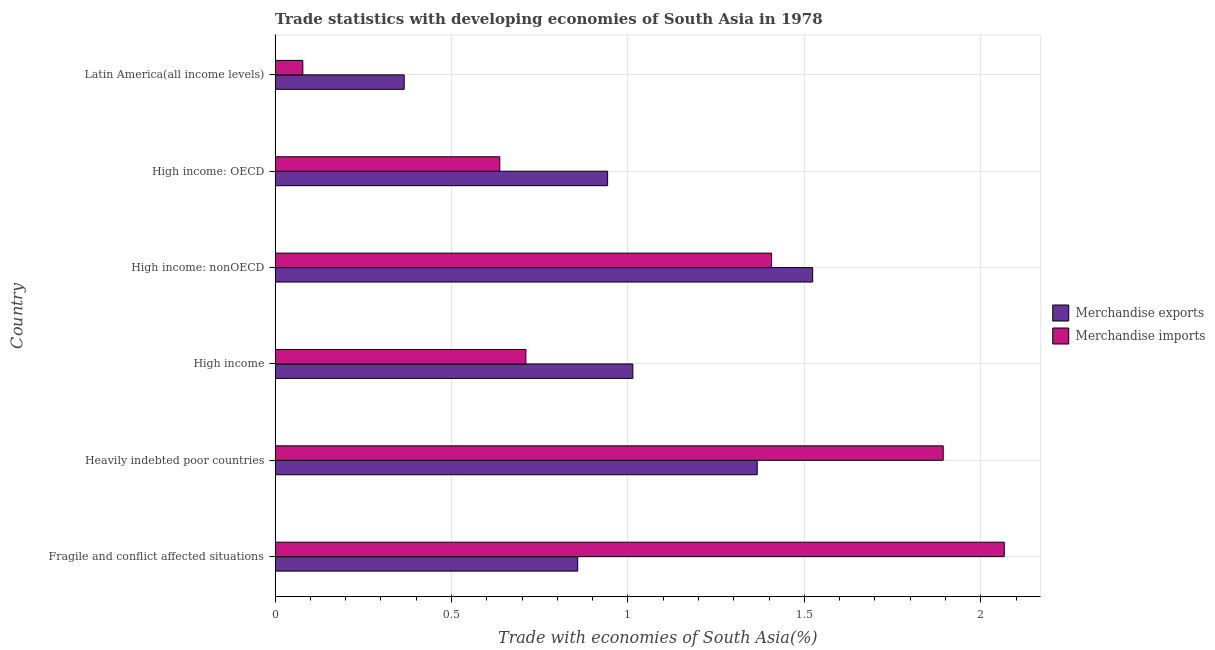How many groups of bars are there?
Keep it short and to the point. 6. Are the number of bars on each tick of the Y-axis equal?
Ensure brevity in your answer.  Yes. How many bars are there on the 1st tick from the top?
Offer a terse response. 2. What is the label of the 1st group of bars from the top?
Provide a succinct answer. Latin America(all income levels). What is the merchandise exports in High income?
Your answer should be compact. 1.01. Across all countries, what is the maximum merchandise imports?
Provide a succinct answer. 2.07. Across all countries, what is the minimum merchandise imports?
Offer a very short reply. 0.08. In which country was the merchandise imports maximum?
Provide a succinct answer. Fragile and conflict affected situations. In which country was the merchandise exports minimum?
Your answer should be compact. Latin America(all income levels). What is the total merchandise imports in the graph?
Your answer should be compact. 6.79. What is the difference between the merchandise imports in Heavily indebted poor countries and that in High income: nonOECD?
Your answer should be compact. 0.49. What is the difference between the merchandise exports in High income: nonOECD and the merchandise imports in Fragile and conflict affected situations?
Provide a short and direct response. -0.54. What is the difference between the merchandise imports and merchandise exports in Latin America(all income levels)?
Provide a short and direct response. -0.29. In how many countries, is the merchandise exports greater than 0.7 %?
Offer a terse response. 5. What is the ratio of the merchandise imports in High income: OECD to that in High income: nonOECD?
Offer a terse response. 0.45. Is the merchandise exports in Fragile and conflict affected situations less than that in Latin America(all income levels)?
Your response must be concise. No. Is the difference between the merchandise imports in Fragile and conflict affected situations and High income: nonOECD greater than the difference between the merchandise exports in Fragile and conflict affected situations and High income: nonOECD?
Provide a succinct answer. Yes. What is the difference between the highest and the second highest merchandise imports?
Offer a very short reply. 0.17. What is the difference between the highest and the lowest merchandise imports?
Your answer should be compact. 1.99. In how many countries, is the merchandise imports greater than the average merchandise imports taken over all countries?
Your answer should be very brief. 3. Is the sum of the merchandise imports in Fragile and conflict affected situations and High income greater than the maximum merchandise exports across all countries?
Offer a terse response. Yes. What does the 1st bar from the top in High income represents?
Your answer should be compact. Merchandise imports. What does the 2nd bar from the bottom in High income: OECD represents?
Keep it short and to the point. Merchandise imports. How many bars are there?
Your response must be concise. 12. Are all the bars in the graph horizontal?
Make the answer very short. Yes. How many countries are there in the graph?
Keep it short and to the point. 6. What is the difference between two consecutive major ticks on the X-axis?
Provide a short and direct response. 0.5. Where does the legend appear in the graph?
Your response must be concise. Center right. How many legend labels are there?
Your response must be concise. 2. How are the legend labels stacked?
Make the answer very short. Vertical. What is the title of the graph?
Keep it short and to the point. Trade statistics with developing economies of South Asia in 1978. What is the label or title of the X-axis?
Offer a terse response. Trade with economies of South Asia(%). What is the Trade with economies of South Asia(%) in Merchandise exports in Fragile and conflict affected situations?
Provide a succinct answer. 0.86. What is the Trade with economies of South Asia(%) of Merchandise imports in Fragile and conflict affected situations?
Keep it short and to the point. 2.07. What is the Trade with economies of South Asia(%) in Merchandise exports in Heavily indebted poor countries?
Keep it short and to the point. 1.37. What is the Trade with economies of South Asia(%) in Merchandise imports in Heavily indebted poor countries?
Keep it short and to the point. 1.89. What is the Trade with economies of South Asia(%) of Merchandise exports in High income?
Provide a succinct answer. 1.01. What is the Trade with economies of South Asia(%) of Merchandise imports in High income?
Your answer should be very brief. 0.71. What is the Trade with economies of South Asia(%) in Merchandise exports in High income: nonOECD?
Offer a terse response. 1.52. What is the Trade with economies of South Asia(%) in Merchandise imports in High income: nonOECD?
Your answer should be compact. 1.41. What is the Trade with economies of South Asia(%) of Merchandise exports in High income: OECD?
Your answer should be very brief. 0.94. What is the Trade with economies of South Asia(%) of Merchandise imports in High income: OECD?
Your answer should be compact. 0.64. What is the Trade with economies of South Asia(%) of Merchandise exports in Latin America(all income levels)?
Your response must be concise. 0.37. What is the Trade with economies of South Asia(%) in Merchandise imports in Latin America(all income levels)?
Provide a succinct answer. 0.08. Across all countries, what is the maximum Trade with economies of South Asia(%) of Merchandise exports?
Keep it short and to the point. 1.52. Across all countries, what is the maximum Trade with economies of South Asia(%) of Merchandise imports?
Provide a succinct answer. 2.07. Across all countries, what is the minimum Trade with economies of South Asia(%) of Merchandise exports?
Your answer should be compact. 0.37. Across all countries, what is the minimum Trade with economies of South Asia(%) in Merchandise imports?
Keep it short and to the point. 0.08. What is the total Trade with economies of South Asia(%) in Merchandise exports in the graph?
Provide a succinct answer. 6.07. What is the total Trade with economies of South Asia(%) in Merchandise imports in the graph?
Your answer should be compact. 6.79. What is the difference between the Trade with economies of South Asia(%) in Merchandise exports in Fragile and conflict affected situations and that in Heavily indebted poor countries?
Your answer should be very brief. -0.51. What is the difference between the Trade with economies of South Asia(%) of Merchandise imports in Fragile and conflict affected situations and that in Heavily indebted poor countries?
Give a very brief answer. 0.17. What is the difference between the Trade with economies of South Asia(%) in Merchandise exports in Fragile and conflict affected situations and that in High income?
Your response must be concise. -0.16. What is the difference between the Trade with economies of South Asia(%) of Merchandise imports in Fragile and conflict affected situations and that in High income?
Provide a short and direct response. 1.36. What is the difference between the Trade with economies of South Asia(%) of Merchandise exports in Fragile and conflict affected situations and that in High income: nonOECD?
Offer a very short reply. -0.67. What is the difference between the Trade with economies of South Asia(%) in Merchandise imports in Fragile and conflict affected situations and that in High income: nonOECD?
Offer a very short reply. 0.66. What is the difference between the Trade with economies of South Asia(%) in Merchandise exports in Fragile and conflict affected situations and that in High income: OECD?
Your answer should be compact. -0.08. What is the difference between the Trade with economies of South Asia(%) in Merchandise imports in Fragile and conflict affected situations and that in High income: OECD?
Ensure brevity in your answer.  1.43. What is the difference between the Trade with economies of South Asia(%) of Merchandise exports in Fragile and conflict affected situations and that in Latin America(all income levels)?
Your answer should be compact. 0.49. What is the difference between the Trade with economies of South Asia(%) in Merchandise imports in Fragile and conflict affected situations and that in Latin America(all income levels)?
Offer a very short reply. 1.99. What is the difference between the Trade with economies of South Asia(%) of Merchandise exports in Heavily indebted poor countries and that in High income?
Offer a terse response. 0.35. What is the difference between the Trade with economies of South Asia(%) of Merchandise imports in Heavily indebted poor countries and that in High income?
Your response must be concise. 1.18. What is the difference between the Trade with economies of South Asia(%) in Merchandise exports in Heavily indebted poor countries and that in High income: nonOECD?
Offer a very short reply. -0.16. What is the difference between the Trade with economies of South Asia(%) of Merchandise imports in Heavily indebted poor countries and that in High income: nonOECD?
Your response must be concise. 0.49. What is the difference between the Trade with economies of South Asia(%) of Merchandise exports in Heavily indebted poor countries and that in High income: OECD?
Your answer should be compact. 0.42. What is the difference between the Trade with economies of South Asia(%) in Merchandise imports in Heavily indebted poor countries and that in High income: OECD?
Your response must be concise. 1.26. What is the difference between the Trade with economies of South Asia(%) of Merchandise imports in Heavily indebted poor countries and that in Latin America(all income levels)?
Ensure brevity in your answer.  1.81. What is the difference between the Trade with economies of South Asia(%) in Merchandise exports in High income and that in High income: nonOECD?
Provide a succinct answer. -0.51. What is the difference between the Trade with economies of South Asia(%) of Merchandise imports in High income and that in High income: nonOECD?
Your response must be concise. -0.7. What is the difference between the Trade with economies of South Asia(%) in Merchandise exports in High income and that in High income: OECD?
Offer a terse response. 0.07. What is the difference between the Trade with economies of South Asia(%) of Merchandise imports in High income and that in High income: OECD?
Provide a succinct answer. 0.07. What is the difference between the Trade with economies of South Asia(%) in Merchandise exports in High income and that in Latin America(all income levels)?
Offer a terse response. 0.65. What is the difference between the Trade with economies of South Asia(%) of Merchandise imports in High income and that in Latin America(all income levels)?
Your response must be concise. 0.63. What is the difference between the Trade with economies of South Asia(%) of Merchandise exports in High income: nonOECD and that in High income: OECD?
Your answer should be very brief. 0.58. What is the difference between the Trade with economies of South Asia(%) of Merchandise imports in High income: nonOECD and that in High income: OECD?
Make the answer very short. 0.77. What is the difference between the Trade with economies of South Asia(%) of Merchandise exports in High income: nonOECD and that in Latin America(all income levels)?
Your answer should be very brief. 1.16. What is the difference between the Trade with economies of South Asia(%) in Merchandise imports in High income: nonOECD and that in Latin America(all income levels)?
Provide a succinct answer. 1.33. What is the difference between the Trade with economies of South Asia(%) in Merchandise exports in High income: OECD and that in Latin America(all income levels)?
Ensure brevity in your answer.  0.58. What is the difference between the Trade with economies of South Asia(%) of Merchandise imports in High income: OECD and that in Latin America(all income levels)?
Make the answer very short. 0.56. What is the difference between the Trade with economies of South Asia(%) of Merchandise exports in Fragile and conflict affected situations and the Trade with economies of South Asia(%) of Merchandise imports in Heavily indebted poor countries?
Offer a very short reply. -1.04. What is the difference between the Trade with economies of South Asia(%) in Merchandise exports in Fragile and conflict affected situations and the Trade with economies of South Asia(%) in Merchandise imports in High income?
Provide a short and direct response. 0.15. What is the difference between the Trade with economies of South Asia(%) of Merchandise exports in Fragile and conflict affected situations and the Trade with economies of South Asia(%) of Merchandise imports in High income: nonOECD?
Keep it short and to the point. -0.55. What is the difference between the Trade with economies of South Asia(%) of Merchandise exports in Fragile and conflict affected situations and the Trade with economies of South Asia(%) of Merchandise imports in High income: OECD?
Ensure brevity in your answer.  0.22. What is the difference between the Trade with economies of South Asia(%) in Merchandise exports in Fragile and conflict affected situations and the Trade with economies of South Asia(%) in Merchandise imports in Latin America(all income levels)?
Make the answer very short. 0.78. What is the difference between the Trade with economies of South Asia(%) of Merchandise exports in Heavily indebted poor countries and the Trade with economies of South Asia(%) of Merchandise imports in High income?
Make the answer very short. 0.66. What is the difference between the Trade with economies of South Asia(%) in Merchandise exports in Heavily indebted poor countries and the Trade with economies of South Asia(%) in Merchandise imports in High income: nonOECD?
Your answer should be compact. -0.04. What is the difference between the Trade with economies of South Asia(%) of Merchandise exports in Heavily indebted poor countries and the Trade with economies of South Asia(%) of Merchandise imports in High income: OECD?
Offer a very short reply. 0.73. What is the difference between the Trade with economies of South Asia(%) of Merchandise exports in Heavily indebted poor countries and the Trade with economies of South Asia(%) of Merchandise imports in Latin America(all income levels)?
Your answer should be very brief. 1.29. What is the difference between the Trade with economies of South Asia(%) in Merchandise exports in High income and the Trade with economies of South Asia(%) in Merchandise imports in High income: nonOECD?
Your answer should be very brief. -0.39. What is the difference between the Trade with economies of South Asia(%) in Merchandise exports in High income and the Trade with economies of South Asia(%) in Merchandise imports in High income: OECD?
Provide a short and direct response. 0.38. What is the difference between the Trade with economies of South Asia(%) in Merchandise exports in High income and the Trade with economies of South Asia(%) in Merchandise imports in Latin America(all income levels)?
Make the answer very short. 0.94. What is the difference between the Trade with economies of South Asia(%) of Merchandise exports in High income: nonOECD and the Trade with economies of South Asia(%) of Merchandise imports in High income: OECD?
Your answer should be very brief. 0.89. What is the difference between the Trade with economies of South Asia(%) of Merchandise exports in High income: nonOECD and the Trade with economies of South Asia(%) of Merchandise imports in Latin America(all income levels)?
Offer a very short reply. 1.44. What is the difference between the Trade with economies of South Asia(%) of Merchandise exports in High income: OECD and the Trade with economies of South Asia(%) of Merchandise imports in Latin America(all income levels)?
Provide a short and direct response. 0.86. What is the average Trade with economies of South Asia(%) of Merchandise exports per country?
Your answer should be very brief. 1.01. What is the average Trade with economies of South Asia(%) of Merchandise imports per country?
Give a very brief answer. 1.13. What is the difference between the Trade with economies of South Asia(%) of Merchandise exports and Trade with economies of South Asia(%) of Merchandise imports in Fragile and conflict affected situations?
Keep it short and to the point. -1.21. What is the difference between the Trade with economies of South Asia(%) in Merchandise exports and Trade with economies of South Asia(%) in Merchandise imports in Heavily indebted poor countries?
Give a very brief answer. -0.53. What is the difference between the Trade with economies of South Asia(%) in Merchandise exports and Trade with economies of South Asia(%) in Merchandise imports in High income?
Keep it short and to the point. 0.3. What is the difference between the Trade with economies of South Asia(%) in Merchandise exports and Trade with economies of South Asia(%) in Merchandise imports in High income: nonOECD?
Your answer should be very brief. 0.12. What is the difference between the Trade with economies of South Asia(%) of Merchandise exports and Trade with economies of South Asia(%) of Merchandise imports in High income: OECD?
Offer a terse response. 0.31. What is the difference between the Trade with economies of South Asia(%) in Merchandise exports and Trade with economies of South Asia(%) in Merchandise imports in Latin America(all income levels)?
Keep it short and to the point. 0.29. What is the ratio of the Trade with economies of South Asia(%) of Merchandise exports in Fragile and conflict affected situations to that in Heavily indebted poor countries?
Offer a very short reply. 0.63. What is the ratio of the Trade with economies of South Asia(%) in Merchandise imports in Fragile and conflict affected situations to that in Heavily indebted poor countries?
Make the answer very short. 1.09. What is the ratio of the Trade with economies of South Asia(%) in Merchandise exports in Fragile and conflict affected situations to that in High income?
Provide a succinct answer. 0.85. What is the ratio of the Trade with economies of South Asia(%) of Merchandise imports in Fragile and conflict affected situations to that in High income?
Give a very brief answer. 2.91. What is the ratio of the Trade with economies of South Asia(%) of Merchandise exports in Fragile and conflict affected situations to that in High income: nonOECD?
Provide a succinct answer. 0.56. What is the ratio of the Trade with economies of South Asia(%) in Merchandise imports in Fragile and conflict affected situations to that in High income: nonOECD?
Ensure brevity in your answer.  1.47. What is the ratio of the Trade with economies of South Asia(%) of Merchandise exports in Fragile and conflict affected situations to that in High income: OECD?
Make the answer very short. 0.91. What is the ratio of the Trade with economies of South Asia(%) in Merchandise imports in Fragile and conflict affected situations to that in High income: OECD?
Your answer should be compact. 3.25. What is the ratio of the Trade with economies of South Asia(%) in Merchandise exports in Fragile and conflict affected situations to that in Latin America(all income levels)?
Ensure brevity in your answer.  2.34. What is the ratio of the Trade with economies of South Asia(%) of Merchandise imports in Fragile and conflict affected situations to that in Latin America(all income levels)?
Your answer should be very brief. 26.28. What is the ratio of the Trade with economies of South Asia(%) in Merchandise exports in Heavily indebted poor countries to that in High income?
Your answer should be compact. 1.35. What is the ratio of the Trade with economies of South Asia(%) of Merchandise imports in Heavily indebted poor countries to that in High income?
Keep it short and to the point. 2.66. What is the ratio of the Trade with economies of South Asia(%) of Merchandise exports in Heavily indebted poor countries to that in High income: nonOECD?
Your answer should be compact. 0.9. What is the ratio of the Trade with economies of South Asia(%) in Merchandise imports in Heavily indebted poor countries to that in High income: nonOECD?
Keep it short and to the point. 1.35. What is the ratio of the Trade with economies of South Asia(%) in Merchandise exports in Heavily indebted poor countries to that in High income: OECD?
Keep it short and to the point. 1.45. What is the ratio of the Trade with economies of South Asia(%) of Merchandise imports in Heavily indebted poor countries to that in High income: OECD?
Ensure brevity in your answer.  2.97. What is the ratio of the Trade with economies of South Asia(%) in Merchandise exports in Heavily indebted poor countries to that in Latin America(all income levels)?
Make the answer very short. 3.73. What is the ratio of the Trade with economies of South Asia(%) of Merchandise imports in Heavily indebted poor countries to that in Latin America(all income levels)?
Offer a very short reply. 24.08. What is the ratio of the Trade with economies of South Asia(%) of Merchandise exports in High income to that in High income: nonOECD?
Give a very brief answer. 0.67. What is the ratio of the Trade with economies of South Asia(%) of Merchandise imports in High income to that in High income: nonOECD?
Ensure brevity in your answer.  0.51. What is the ratio of the Trade with economies of South Asia(%) in Merchandise exports in High income to that in High income: OECD?
Ensure brevity in your answer.  1.08. What is the ratio of the Trade with economies of South Asia(%) of Merchandise imports in High income to that in High income: OECD?
Give a very brief answer. 1.12. What is the ratio of the Trade with economies of South Asia(%) in Merchandise exports in High income to that in Latin America(all income levels)?
Your answer should be compact. 2.77. What is the ratio of the Trade with economies of South Asia(%) of Merchandise imports in High income to that in Latin America(all income levels)?
Keep it short and to the point. 9.04. What is the ratio of the Trade with economies of South Asia(%) of Merchandise exports in High income: nonOECD to that in High income: OECD?
Make the answer very short. 1.62. What is the ratio of the Trade with economies of South Asia(%) in Merchandise imports in High income: nonOECD to that in High income: OECD?
Give a very brief answer. 2.21. What is the ratio of the Trade with economies of South Asia(%) of Merchandise exports in High income: nonOECD to that in Latin America(all income levels)?
Ensure brevity in your answer.  4.16. What is the ratio of the Trade with economies of South Asia(%) of Merchandise imports in High income: nonOECD to that in Latin America(all income levels)?
Provide a short and direct response. 17.89. What is the ratio of the Trade with economies of South Asia(%) of Merchandise exports in High income: OECD to that in Latin America(all income levels)?
Your response must be concise. 2.58. What is the ratio of the Trade with economies of South Asia(%) of Merchandise imports in High income: OECD to that in Latin America(all income levels)?
Provide a succinct answer. 8.1. What is the difference between the highest and the second highest Trade with economies of South Asia(%) of Merchandise exports?
Provide a succinct answer. 0.16. What is the difference between the highest and the second highest Trade with economies of South Asia(%) of Merchandise imports?
Provide a succinct answer. 0.17. What is the difference between the highest and the lowest Trade with economies of South Asia(%) of Merchandise exports?
Your answer should be compact. 1.16. What is the difference between the highest and the lowest Trade with economies of South Asia(%) in Merchandise imports?
Provide a short and direct response. 1.99. 